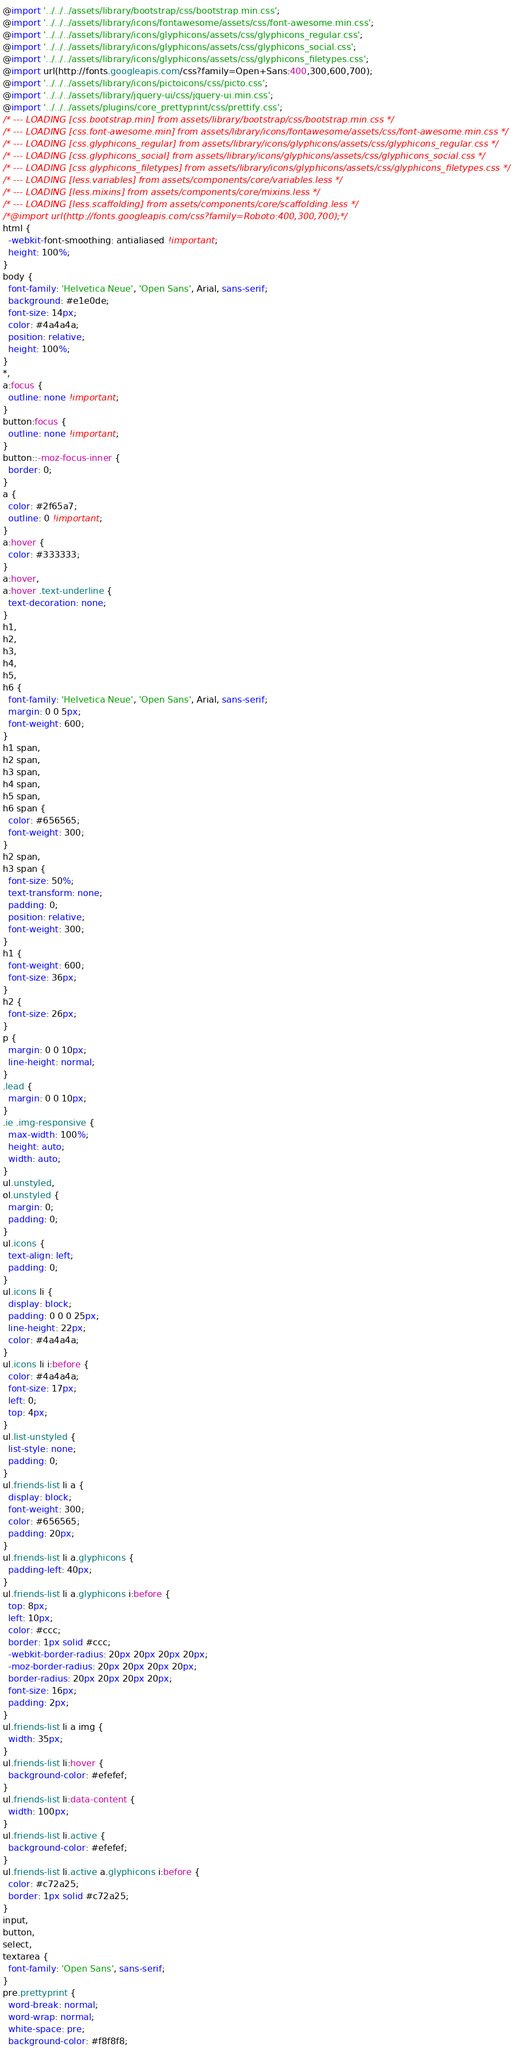Convert code to text. <code><loc_0><loc_0><loc_500><loc_500><_CSS_>@import '../../../assets/library/bootstrap/css/bootstrap.min.css';
@import '../../../assets/library/icons/fontawesome/assets/css/font-awesome.min.css';
@import '../../../assets/library/icons/glyphicons/assets/css/glyphicons_regular.css';
@import '../../../assets/library/icons/glyphicons/assets/css/glyphicons_social.css';
@import '../../../assets/library/icons/glyphicons/assets/css/glyphicons_filetypes.css';
@import url(http://fonts.googleapis.com/css?family=Open+Sans:400,300,600,700);
@import '../../../assets/library/icons/pictoicons/css/picto.css';
@import '../../../assets/library/jquery-ui/css/jquery-ui.min.css';
@import '../../../assets/plugins/core_prettyprint/css/prettify.css';
/* --- LOADING [css.bootstrap.min] from assets/library/bootstrap/css/bootstrap.min.css */
/* --- LOADING [css.font-awesome.min] from assets/library/icons/fontawesome/assets/css/font-awesome.min.css */
/* --- LOADING [css.glyphicons_regular] from assets/library/icons/glyphicons/assets/css/glyphicons_regular.css */
/* --- LOADING [css.glyphicons_social] from assets/library/icons/glyphicons/assets/css/glyphicons_social.css */
/* --- LOADING [css.glyphicons_filetypes] from assets/library/icons/glyphicons/assets/css/glyphicons_filetypes.css */
/* --- LOADING [less.variables] from assets/components/core/variables.less */
/* --- LOADING [less.mixins] from assets/components/core/mixins.less */
/* --- LOADING [less.scaffolding] from assets/components/core/scaffolding.less */
/*@import url(http://fonts.googleapis.com/css?family=Roboto:400,300,700);*/
html {
  -webkit-font-smoothing: antialiased !important;
  height: 100%;
}
body {
  font-family: 'Helvetica Neue', 'Open Sans', Arial, sans-serif;
  background: #e1e0de;
  font-size: 14px;
  color: #4a4a4a;
  position: relative;
  height: 100%;
}
*,
a:focus {
  outline: none !important;
}
button:focus {
  outline: none !important;
}
button::-moz-focus-inner {
  border: 0;
}
a {
  color: #2f65a7;
  outline: 0 !important;
}
a:hover {
  color: #333333;
}
a:hover,
a:hover .text-underline {
  text-decoration: none;
}
h1,
h2,
h3,
h4,
h5,
h6 {
  font-family: 'Helvetica Neue', 'Open Sans', Arial, sans-serif;
  margin: 0 0 5px;
  font-weight: 600;
}
h1 span,
h2 span,
h3 span,
h4 span,
h5 span,
h6 span {
  color: #656565;
  font-weight: 300;
}
h2 span,
h3 span {
  font-size: 50%;
  text-transform: none;
  padding: 0;
  position: relative;
  font-weight: 300;
}
h1 {
  font-weight: 600;
  font-size: 36px;
}
h2 {
  font-size: 26px;
}
p {
  margin: 0 0 10px;
  line-height: normal;
}
.lead {
  margin: 0 0 10px;
}
.ie .img-responsive {
  max-width: 100%;
  height: auto;
  width: auto;
}
ul.unstyled,
ol.unstyled {
  margin: 0;
  padding: 0;
}
ul.icons {
  text-align: left;
  padding: 0;
}
ul.icons li {
  display: block;
  padding: 0 0 0 25px;
  line-height: 22px;
  color: #4a4a4a;
}
ul.icons li i:before {
  color: #4a4a4a;
  font-size: 17px;
  left: 0;
  top: 4px;
}
ul.list-unstyled {
  list-style: none;
  padding: 0;
}
ul.friends-list li a {
  display: block;
  font-weight: 300;
  color: #656565;
  padding: 20px;
}
ul.friends-list li a.glyphicons {
  padding-left: 40px;
}
ul.friends-list li a.glyphicons i:before {
  top: 8px;
  left: 10px;
  color: #ccc;
  border: 1px solid #ccc;
  -webkit-border-radius: 20px 20px 20px 20px;
  -moz-border-radius: 20px 20px 20px 20px;
  border-radius: 20px 20px 20px 20px;
  font-size: 16px;
  padding: 2px;
}
ul.friends-list li a img {
  width: 35px;
}
ul.friends-list li:hover {
  background-color: #efefef;
}
ul.friends-list li:data-content {
  width: 100px;
}
ul.friends-list li.active {
  background-color: #efefef;
}
ul.friends-list li.active a.glyphicons i:before {
  color: #c72a25;
  border: 1px solid #c72a25;
}
input,
button,
select,
textarea {
  font-family: 'Open Sans', sans-serif;
}
pre.prettyprint {
  word-break: normal;
  word-wrap: normal;
  white-space: pre;
  background-color: #f8f8f8;</code> 